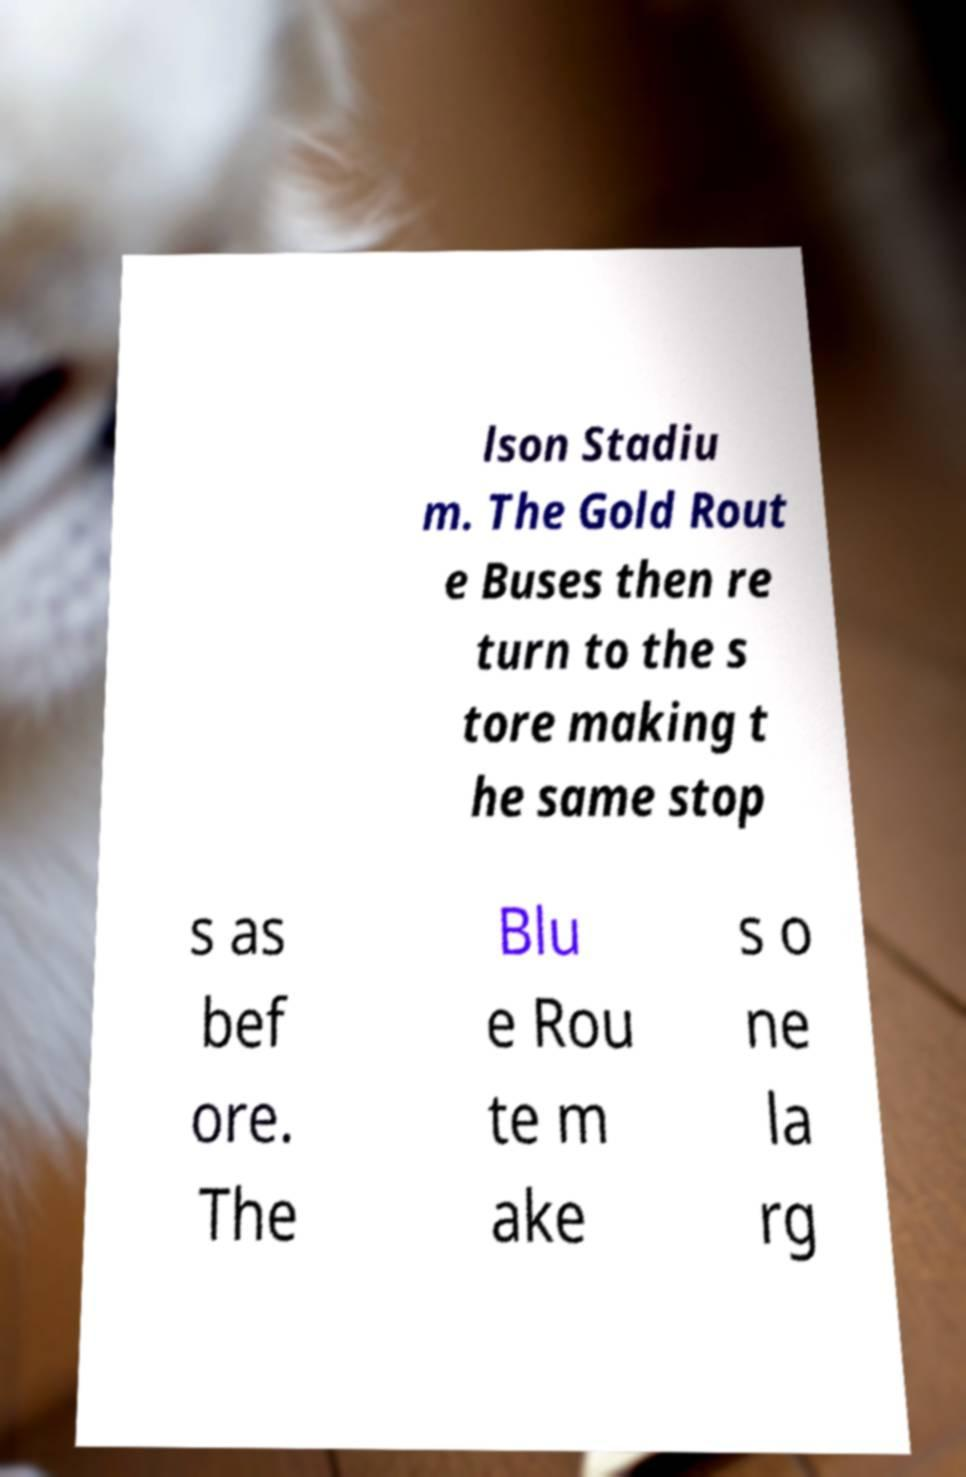There's text embedded in this image that I need extracted. Can you transcribe it verbatim? lson Stadiu m. The Gold Rout e Buses then re turn to the s tore making t he same stop s as bef ore. The Blu e Rou te m ake s o ne la rg 